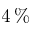Convert formula to latex. <formula><loc_0><loc_0><loc_500><loc_500>4 \, \%</formula> 